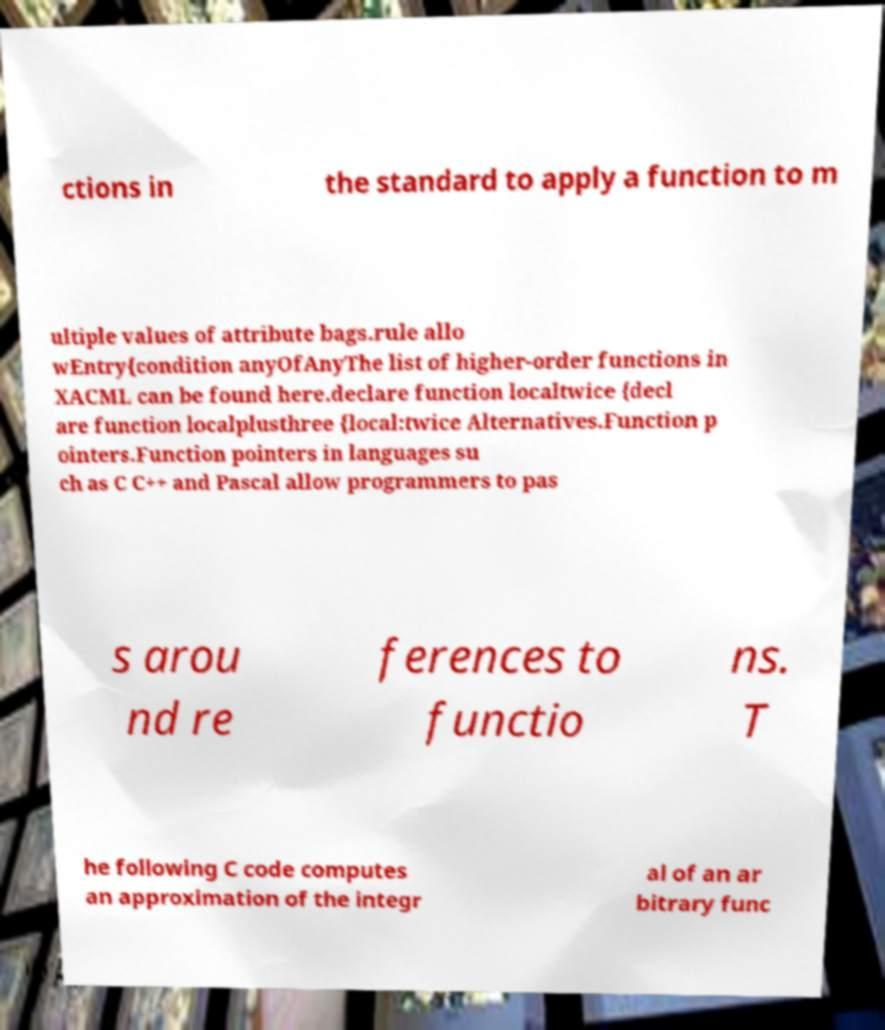Please identify and transcribe the text found in this image. ctions in the standard to apply a function to m ultiple values of attribute bags.rule allo wEntry{condition anyOfAnyThe list of higher-order functions in XACML can be found here.declare function localtwice {decl are function localplusthree {local:twice Alternatives.Function p ointers.Function pointers in languages su ch as C C++ and Pascal allow programmers to pas s arou nd re ferences to functio ns. T he following C code computes an approximation of the integr al of an ar bitrary func 